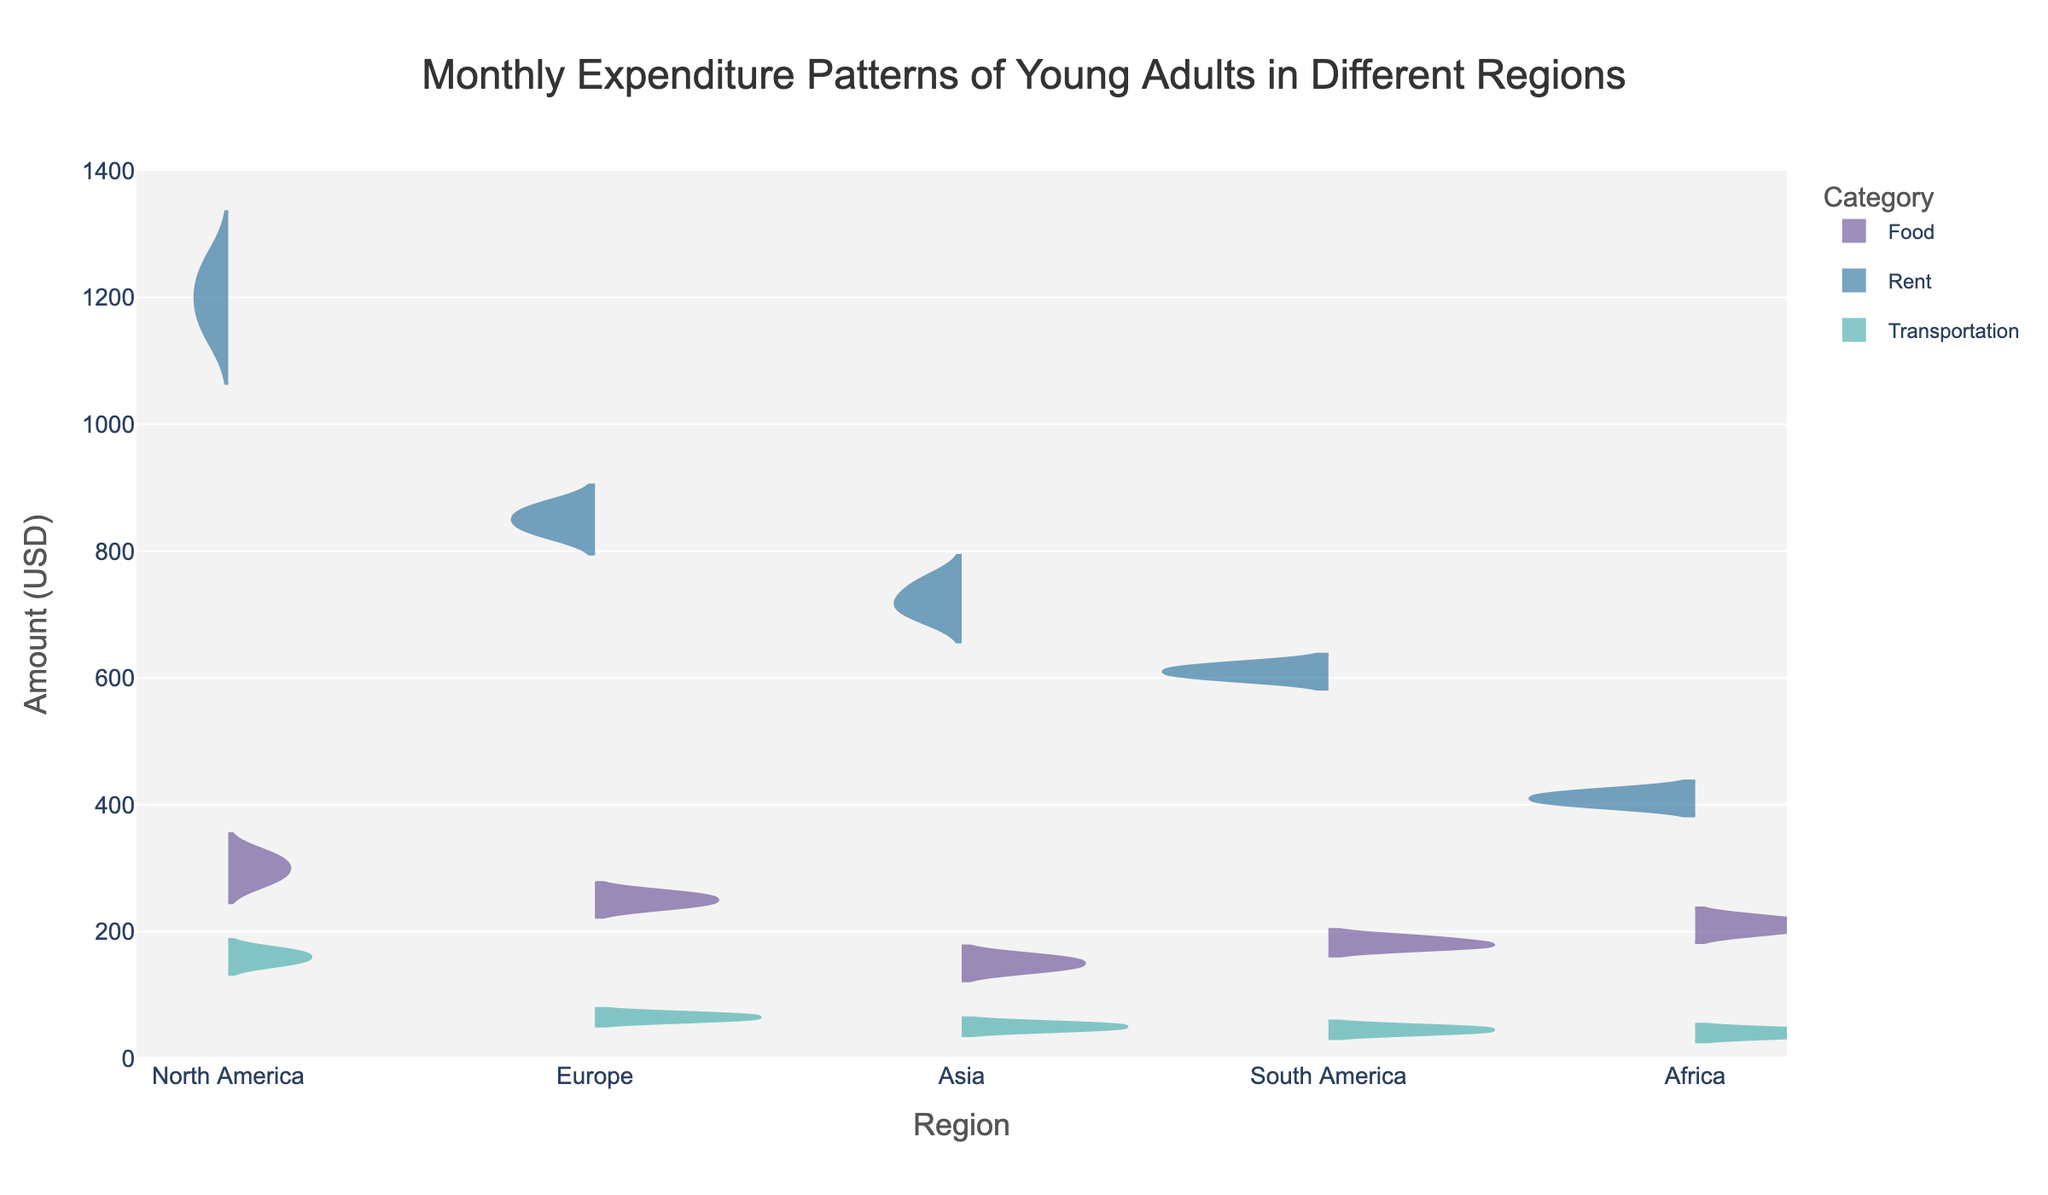What is the title of the figure? The title is usually displayed at the top of the figure. Here, "Monthly Expenditure Patterns of Young Adults in Different Regions" is prominently displayed.
Answer: Monthly Expenditure Patterns of Young Adults in Different Regions Which region has the highest median rent expenditure? The box plots overlaying the violin plots show the median as a line within the box. North America has the highest median rent expenditure, shown by their median line around 1200 USD.
Answer: North America What is the range of transportation expenditure in Asia? The range of a category can be observed from the lowest to the highest points of the violin plot. For Asia, the lowest transportation expenditure is 45 USD, and the highest is 55 USD, giving a range of 10 USD.
Answer: 10 USD How does the median food expenditure in Europe compare to that in Africa? The median expenditure is indicated by the horizontal line inside the box plot. Europe has a median food expenditure around 250-260 USD, while Africa's median for food is around 210-220 USD. Europe’s median is higher.
Answer: Europe’s median is higher Which category has the most consistent expenditure in South America? Consistency can be inferred from the width of the violin plot. Narrower plots suggest less variability. In South America, transportation has the narrowest violin plot indicating the most consistent expenditure.
Answer: Transportation What is the average rent expenditure in Africa? Average values are not directly provided but can be estimated by looking at the box plot and violin plot. The median is around 410 USD and the distribution seems symmetrical, thus the average is approximately 410 USD.
Answer: Approximately 410 USD How does the food expenditure in North America differ from that in Asia? The range and distribution of expenditures are wider in North America (280-320 USD) compared to Asia (140-160 USD). North America's food expenditure is higher and more spread out than Asia's.
Answer: Higher and more spread out Which region has the smallest median transportation expenditure? The smallest median can be identified by the lowest horizontal line within the transportation violin plots. South America has the smallest median transportation expenditure at around 45 USD.
Answer: South America What is the mode of the rent expenditure category in Europe? The mode is not visible on violin plots, but assuming the most frequent value is around the peak of the distribution. In Europe, the most frequent (mode) rent expenditure seems to be around 850 USD.
Answer: Approximately 850 USD 